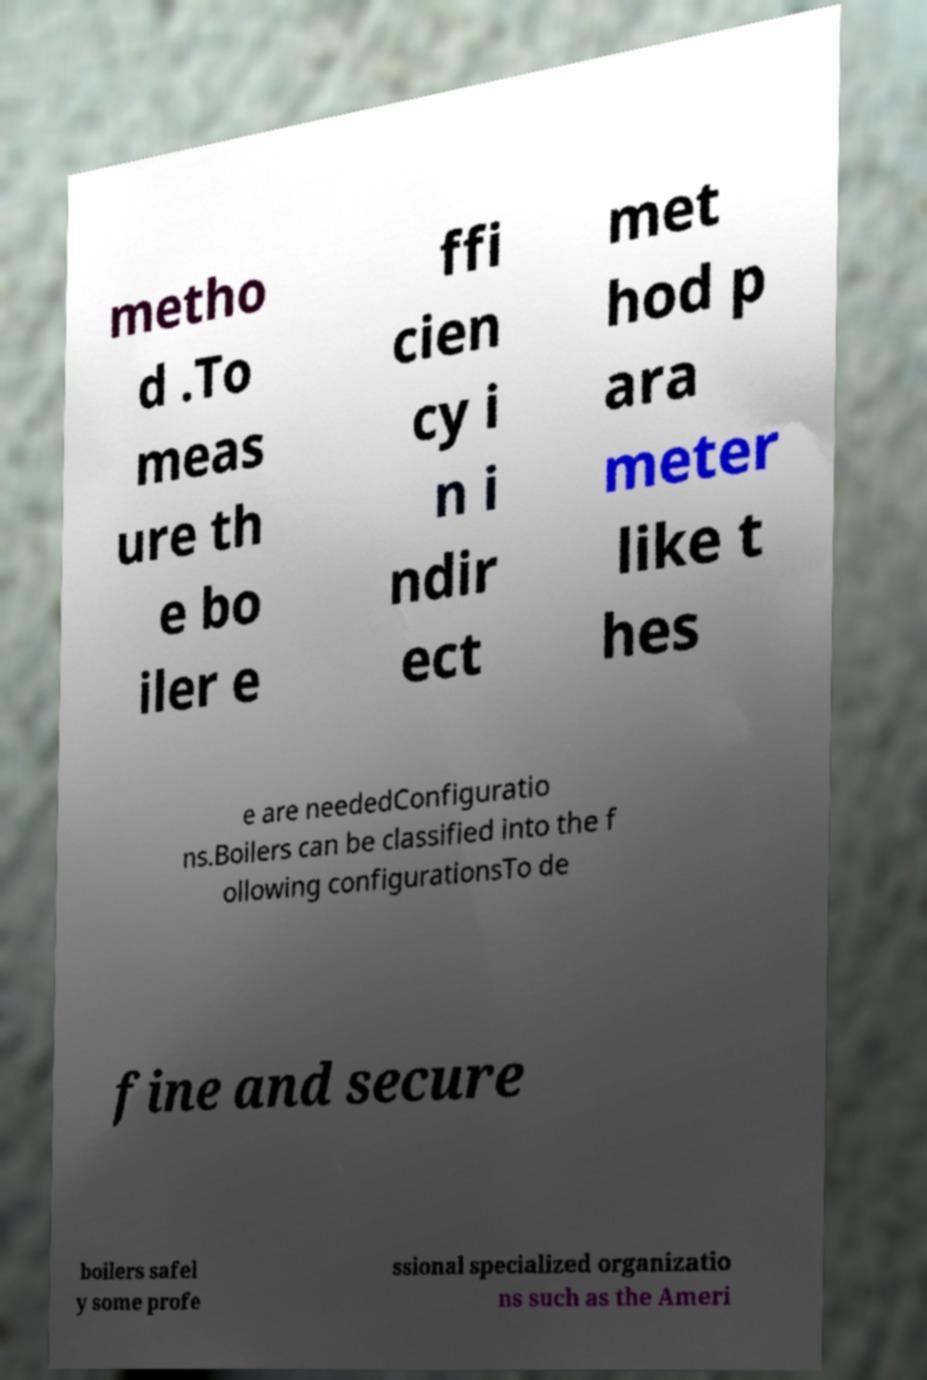Could you extract and type out the text from this image? metho d .To meas ure th e bo iler e ffi cien cy i n i ndir ect met hod p ara meter like t hes e are neededConfiguratio ns.Boilers can be classified into the f ollowing configurationsTo de fine and secure boilers safel y some profe ssional specialized organizatio ns such as the Ameri 